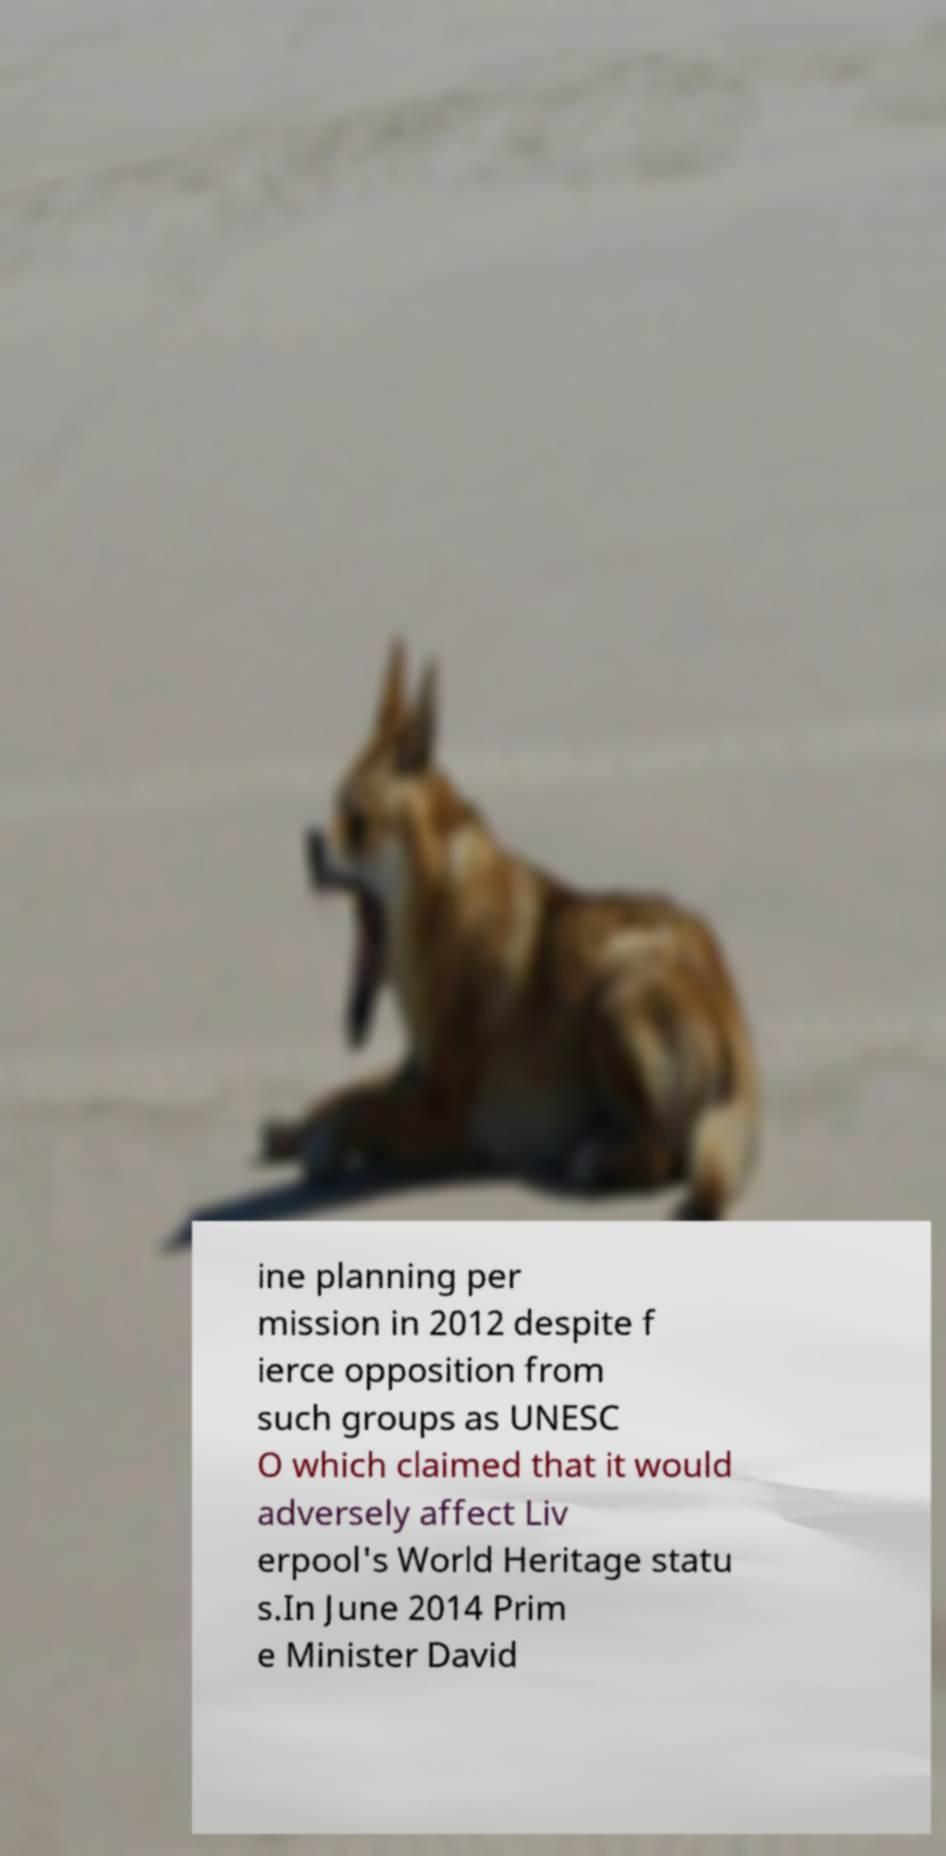There's text embedded in this image that I need extracted. Can you transcribe it verbatim? ine planning per mission in 2012 despite f ierce opposition from such groups as UNESC O which claimed that it would adversely affect Liv erpool's World Heritage statu s.In June 2014 Prim e Minister David 